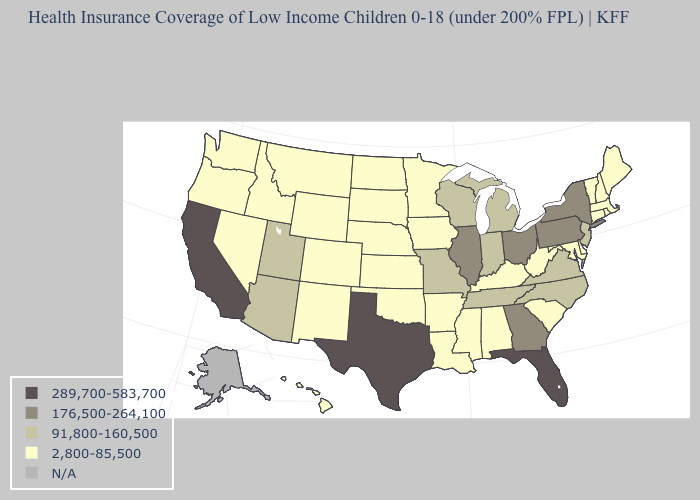What is the lowest value in the MidWest?
Give a very brief answer. 2,800-85,500. What is the lowest value in states that border Ohio?
Keep it brief. 2,800-85,500. What is the value of Arizona?
Write a very short answer. 91,800-160,500. What is the lowest value in the West?
Answer briefly. 2,800-85,500. Which states have the lowest value in the USA?
Quick response, please. Alabama, Arkansas, Colorado, Connecticut, Delaware, Hawaii, Idaho, Iowa, Kansas, Kentucky, Louisiana, Maine, Maryland, Massachusetts, Minnesota, Mississippi, Montana, Nebraska, Nevada, New Hampshire, New Mexico, North Dakota, Oklahoma, Oregon, Rhode Island, South Carolina, South Dakota, Vermont, Washington, West Virginia, Wyoming. Does the first symbol in the legend represent the smallest category?
Short answer required. No. What is the value of Mississippi?
Be succinct. 2,800-85,500. Name the states that have a value in the range 289,700-583,700?
Answer briefly. California, Florida, Texas. What is the value of Nebraska?
Concise answer only. 2,800-85,500. What is the highest value in states that border Arizona?
Keep it brief. 289,700-583,700. Does Oklahoma have the highest value in the South?
Keep it brief. No. Name the states that have a value in the range 2,800-85,500?
Concise answer only. Alabama, Arkansas, Colorado, Connecticut, Delaware, Hawaii, Idaho, Iowa, Kansas, Kentucky, Louisiana, Maine, Maryland, Massachusetts, Minnesota, Mississippi, Montana, Nebraska, Nevada, New Hampshire, New Mexico, North Dakota, Oklahoma, Oregon, Rhode Island, South Carolina, South Dakota, Vermont, Washington, West Virginia, Wyoming. What is the highest value in the South ?
Write a very short answer. 289,700-583,700. What is the value of New Hampshire?
Write a very short answer. 2,800-85,500. 